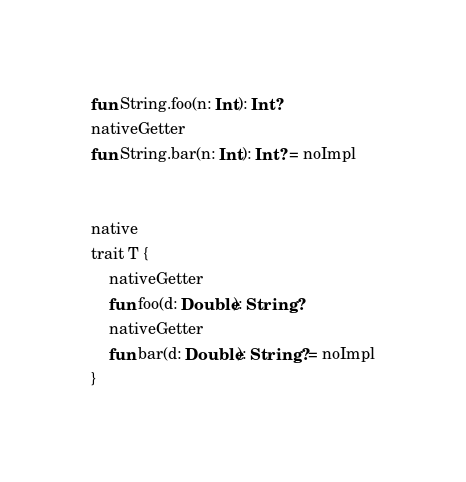<code> <loc_0><loc_0><loc_500><loc_500><_Kotlin_>fun String.foo(n: Int): Int?
nativeGetter
fun String.bar(n: Int): Int? = noImpl


native
trait T {
    nativeGetter
    fun foo(d: Double): String?
    nativeGetter
    fun bar(d: Double): String? = noImpl
}</code> 